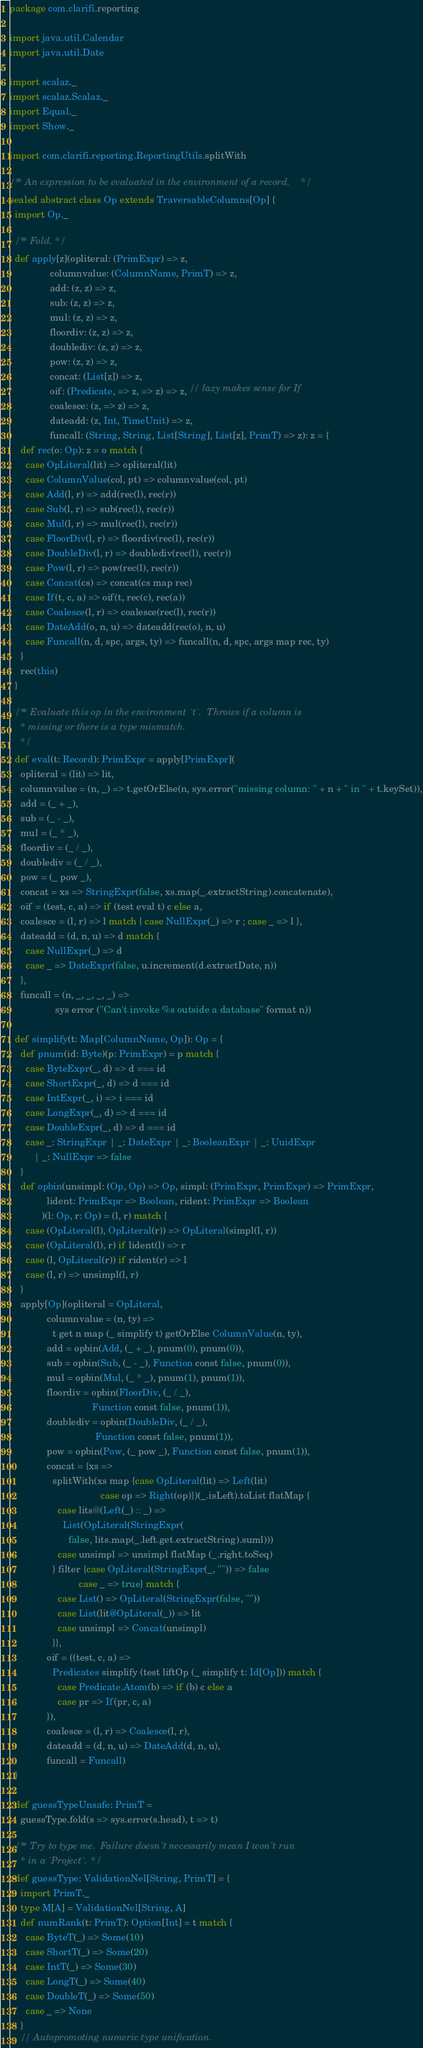<code> <loc_0><loc_0><loc_500><loc_500><_Scala_>package com.clarifi.reporting

import java.util.Calendar
import java.util.Date

import scalaz._
import scalaz.Scalaz._
import Equal._
import Show._

import com.clarifi.reporting.ReportingUtils.splitWith

/** An expression to be evaluated in the environment of a record. */
sealed abstract class Op extends TraversableColumns[Op] {
  import Op._

  /** Fold. */
  def apply[z](opliteral: (PrimExpr) => z,
               columnvalue: (ColumnName, PrimT) => z,
               add: (z, z) => z,
               sub: (z, z) => z,
               mul: (z, z) => z,
               floordiv: (z, z) => z,
               doublediv: (z, z) => z,
               pow: (z, z) => z,
               concat: (List[z]) => z,
               oif: (Predicate, => z, => z) => z, // lazy makes sense for If
               coalesce: (z, => z) => z,
               dateadd: (z, Int, TimeUnit) => z,
               funcall: (String, String, List[String], List[z], PrimT) => z): z = {
    def rec(o: Op): z = o match {
      case OpLiteral(lit) => opliteral(lit)
      case ColumnValue(col, pt) => columnvalue(col, pt)
      case Add(l, r) => add(rec(l), rec(r))
      case Sub(l, r) => sub(rec(l), rec(r))
      case Mul(l, r) => mul(rec(l), rec(r))
      case FloorDiv(l, r) => floordiv(rec(l), rec(r))
      case DoubleDiv(l, r) => doublediv(rec(l), rec(r))
      case Pow(l, r) => pow(rec(l), rec(r))
      case Concat(cs) => concat(cs map rec)
      case If(t, c, a) => oif(t, rec(c), rec(a))
      case Coalesce(l, r) => coalesce(rec(l), rec(r))
      case DateAdd(o, n, u) => dateadd(rec(o), n, u)
      case Funcall(n, d, spc, args, ty) => funcall(n, d, spc, args map rec, ty)
    }
    rec(this)
  }

  /** Evaluate this op in the environment `t`.  Throws if a column is
    * missing or there is a type mismatch.
    */
  def eval(t: Record): PrimExpr = apply[PrimExpr](
    opliteral = (lit) => lit,
    columnvalue = (n, _) => t.getOrElse(n, sys.error("missing column: " + n + " in " + t.keySet)),
    add = (_ + _),
    sub = (_ - _),
    mul = (_ * _),
    floordiv = (_ / _),
    doublediv = (_ / _),
    pow = (_ pow _),
    concat = xs => StringExpr(false, xs.map(_.extractString).concatenate),
    oif = (test, c, a) => if (test eval t) c else a,
    coalesce = (l, r) => l match { case NullExpr(_) => r ; case _ => l },
    dateadd = (d, n, u) => d match {
      case NullExpr(_) => d
      case _ => DateExpr(false, u.increment(d.extractDate, n))
    },
    funcall = (n, _, _, _, _) =>
                 sys error ("Can't invoke %s outside a database" format n))

  def simplify(t: Map[ColumnName, Op]): Op = {
    def pnum(id: Byte)(p: PrimExpr) = p match {
      case ByteExpr(_, d) => d === id
      case ShortExpr(_, d) => d === id
      case IntExpr(_, i) => i === id
      case LongExpr(_, d) => d === id
      case DoubleExpr(_, d) => d === id
      case _: StringExpr | _: DateExpr | _: BooleanExpr | _: UuidExpr
         | _: NullExpr => false
    }
    def opbin(unsimpl: (Op, Op) => Op, simpl: (PrimExpr, PrimExpr) => PrimExpr,
              lident: PrimExpr => Boolean, rident: PrimExpr => Boolean
            )(l: Op, r: Op) = (l, r) match {
      case (OpLiteral(l), OpLiteral(r)) => OpLiteral(simpl(l, r))
      case (OpLiteral(l), r) if lident(l) => r
      case (l, OpLiteral(r)) if rident(r) => l
      case (l, r) => unsimpl(l, r)
    }
    apply[Op](opliteral = OpLiteral,
              columnvalue = (n, ty) =>
                t get n map (_ simplify t) getOrElse ColumnValue(n, ty),
              add = opbin(Add, (_ + _), pnum(0), pnum(0)),
              sub = opbin(Sub, (_ - _), Function const false, pnum(0)),
              mul = opbin(Mul, (_ * _), pnum(1), pnum(1)),
              floordiv = opbin(FloorDiv, (_ / _),
                               Function const false, pnum(1)),
              doublediv = opbin(DoubleDiv, (_ / _),
                                Function const false, pnum(1)),
              pow = opbin(Pow, (_ pow _), Function const false, pnum(1)),
              concat = {xs =>
                splitWith(xs map {case OpLiteral(lit) => Left(lit)
                                  case op => Right(op)})(_.isLeft).toList flatMap {
                  case lits@(Left(_) :: _) =>
                    List(OpLiteral(StringExpr(
                      false, lits.map(_.left.get.extractString).suml)))
                  case unsimpl => unsimpl flatMap (_.right.toSeq)
                } filter {case OpLiteral(StringExpr(_, "")) => false
                          case _ => true} match {
                  case List() => OpLiteral(StringExpr(false, ""))
                  case List(lit@OpLiteral(_)) => lit
                  case unsimpl => Concat(unsimpl)
                }},
              oif = ((test, c, a) =>
                Predicates simplify (test liftOp (_ simplify t: Id[Op])) match {
                  case Predicate.Atom(b) => if (b) c else a
                  case pr => If(pr, c, a)
              }),
              coalesce = (l, r) => Coalesce(l, r),
              dateadd = (d, n, u) => DateAdd(d, n, u),
              funcall = Funcall)
  }

  def guessTypeUnsafe: PrimT =
    guessType.fold(s => sys.error(s.head), t => t)

  /** Try to type me.  Failure doesn't necessarily mean I won't run
    * in a `Project`. */
  def guessType: ValidationNel[String, PrimT] = {
    import PrimT._
    type M[A] = ValidationNel[String, A]
    def numRank(t: PrimT): Option[Int] = t match {
      case ByteT(_) => Some(10)
      case ShortT(_) => Some(20)
      case IntT(_) => Some(30)
      case LongT(_) => Some(40)
      case DoubleT(_) => Some(50)
      case _ => None
    }
    // Autopromoting numeric type unification.</code> 